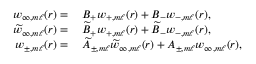<formula> <loc_0><loc_0><loc_500><loc_500>\begin{array} { r l } { w _ { \infty , m \ell } ( r ) = } & { \, B _ { + } w _ { + , m \ell } ( r ) + B _ { - } w _ { - , m \ell } ( r ) , } \\ { \widetilde { w } _ { \infty , m \ell } ( r ) = } & { \, \widetilde { B } _ { + } w _ { + , m \ell } ( r ) + \widetilde { B } _ { - } w _ { - , m \ell } ( r ) , } \\ { w _ { \pm , m \ell } ( r ) = } & { \, \widetilde { A } _ { \pm , m \ell } \widetilde { w } _ { \infty , m \ell } ( r ) + { A } _ { \pm , m \ell } w _ { \infty , m \ell } ( r ) , } \end{array}</formula> 